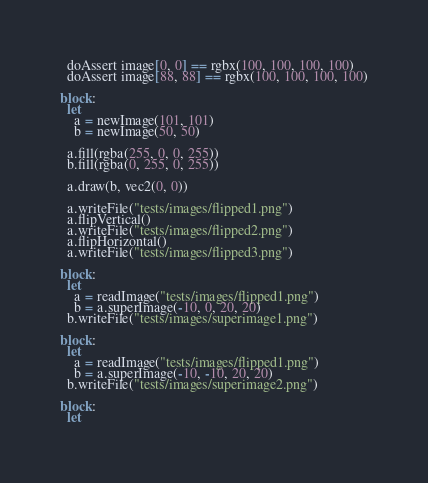<code> <loc_0><loc_0><loc_500><loc_500><_Nim_>  doAssert image[0, 0] == rgbx(100, 100, 100, 100)
  doAssert image[88, 88] == rgbx(100, 100, 100, 100)

block:
  let
    a = newImage(101, 101)
    b = newImage(50, 50)

  a.fill(rgba(255, 0, 0, 255))
  b.fill(rgba(0, 255, 0, 255))

  a.draw(b, vec2(0, 0))

  a.writeFile("tests/images/flipped1.png")
  a.flipVertical()
  a.writeFile("tests/images/flipped2.png")
  a.flipHorizontal()
  a.writeFile("tests/images/flipped3.png")

block:
  let
    a = readImage("tests/images/flipped1.png")
    b = a.superImage(-10, 0, 20, 20)
  b.writeFile("tests/images/superimage1.png")

block:
  let
    a = readImage("tests/images/flipped1.png")
    b = a.superImage(-10, -10, 20, 20)
  b.writeFile("tests/images/superimage2.png")

block:
  let</code> 